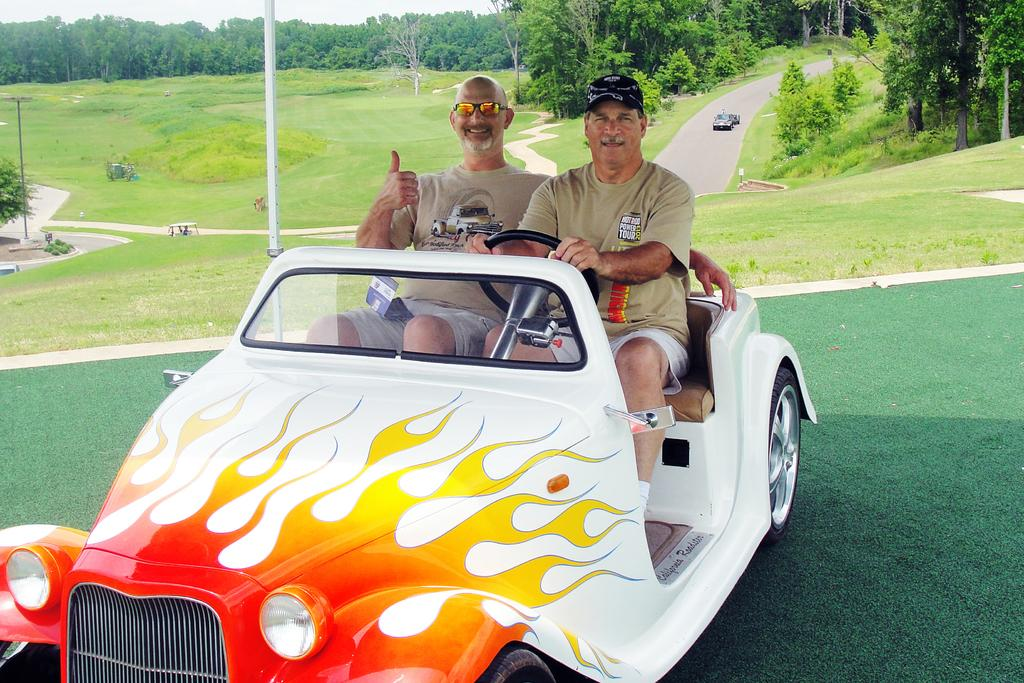How many people are in the car in the image? There are two persons sitting in a white car in the image. What can be seen in the background behind the car? There are many trees and a road visible in the background. Are there any other vehicles present in the image? Yes, there are other cars present in the background. Where is the sofa located in the image? There is no sofa present in the image. What is your mom doing in the image? The image does not show your mom, so we cannot answer that question. 